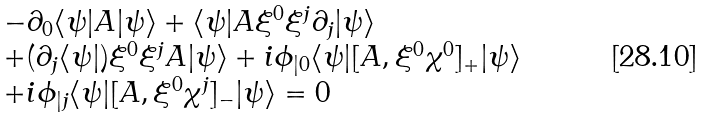Convert formula to latex. <formula><loc_0><loc_0><loc_500><loc_500>\begin{array} { l } - \partial _ { 0 } \langle \psi | A | \psi \rangle + \langle \psi | A \xi ^ { 0 } \xi ^ { j } \partial _ { j } | \psi \rangle \\ + ( \partial _ { j } \langle \psi | ) \xi ^ { 0 } \xi ^ { j } A | \psi \rangle + i \phi _ { | 0 } \langle \psi | [ A , \xi ^ { 0 } \chi ^ { 0 } ] _ { + } | \psi \rangle \\ + i \phi _ { | j } \langle \psi | [ A , \xi ^ { 0 } \chi ^ { j } ] _ { - } | \psi \rangle = 0 \end{array}</formula> 